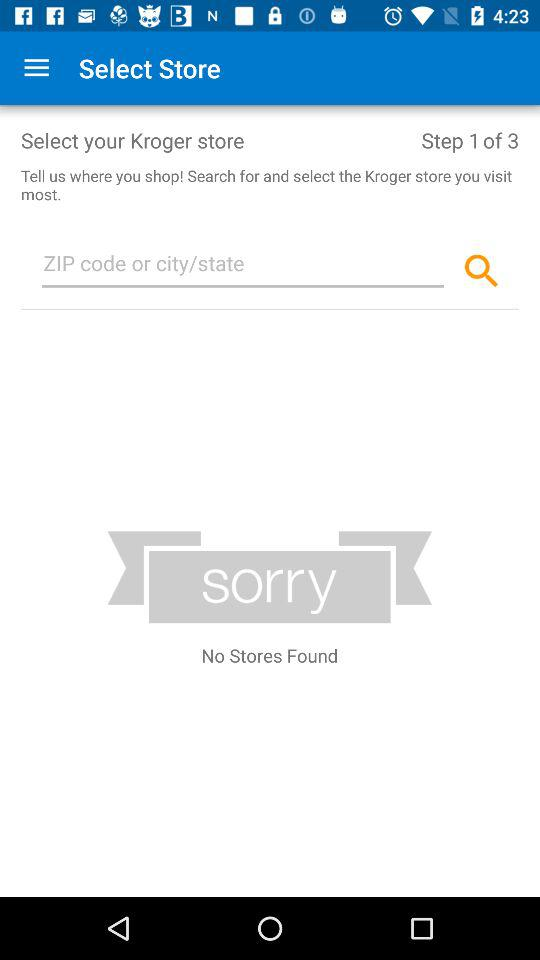How many steps in total are there? There are 3 steps. 